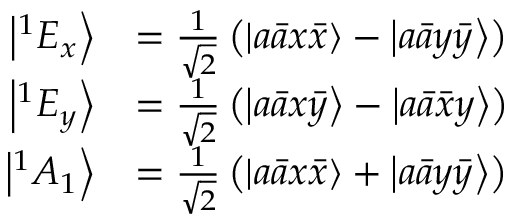Convert formula to latex. <formula><loc_0><loc_0><loc_500><loc_500>\begin{array} { r l } { \left | ^ { 1 } E _ { x } \right \rangle } & { = \frac { 1 } { \sqrt { 2 } } \left ( \left | a \bar { a } x \bar { x } \right \rangle - \left | a \bar { a } y \bar { y } \right \rangle \right ) } \\ { \left | ^ { 1 } E _ { y } \right \rangle } & { = \frac { 1 } { \sqrt { 2 } } \left ( \left | a \bar { a } x \bar { y } \right \rangle - \left | a \bar { a } \bar { x } y \right \rangle \right ) } \\ { \left | ^ { 1 } A _ { 1 } \right \rangle } & { = \frac { 1 } { \sqrt { 2 } } \left ( \left | a \bar { a } x \bar { x } \right \rangle + \left | a \bar { a } y \bar { y } \right \rangle \right ) } \end{array}</formula> 